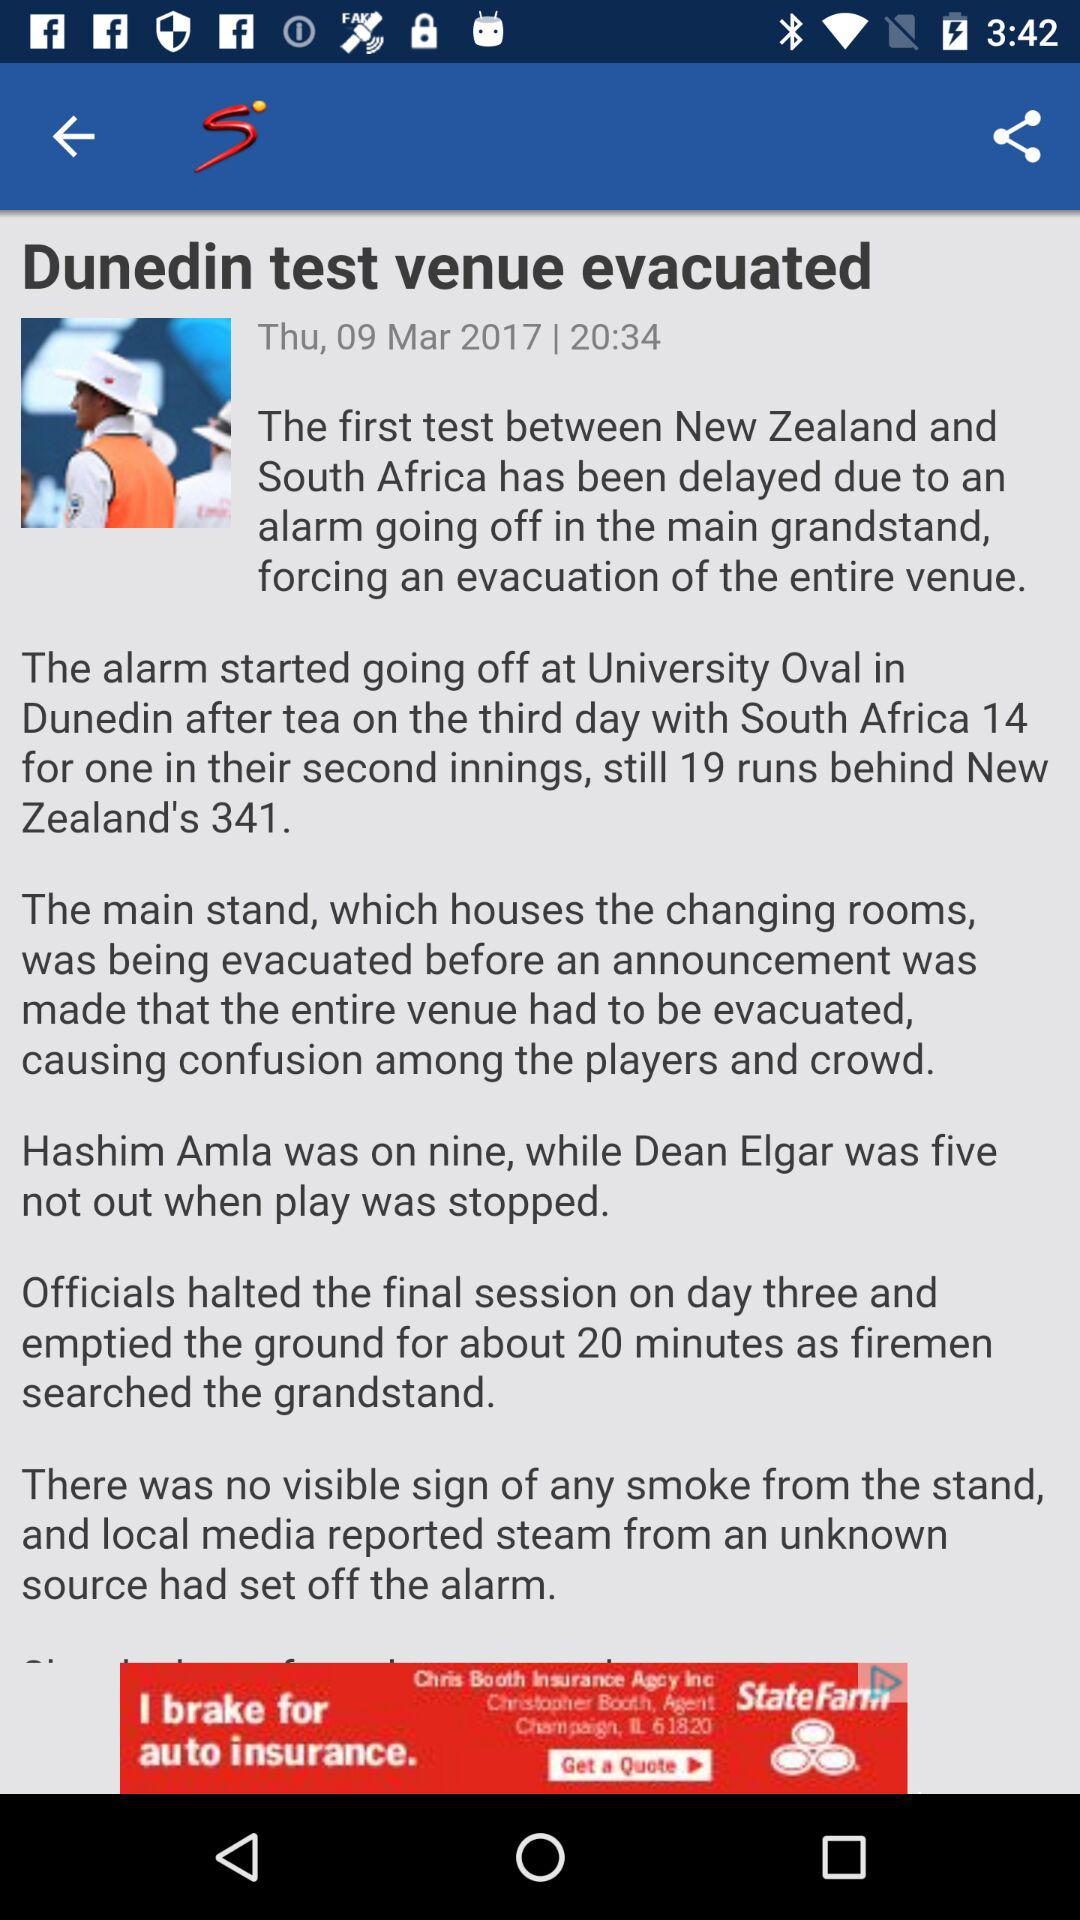When will the first test match between "New Zealand" and "South Africa" resume?
When the provided information is insufficient, respond with <no answer>. <no answer> 